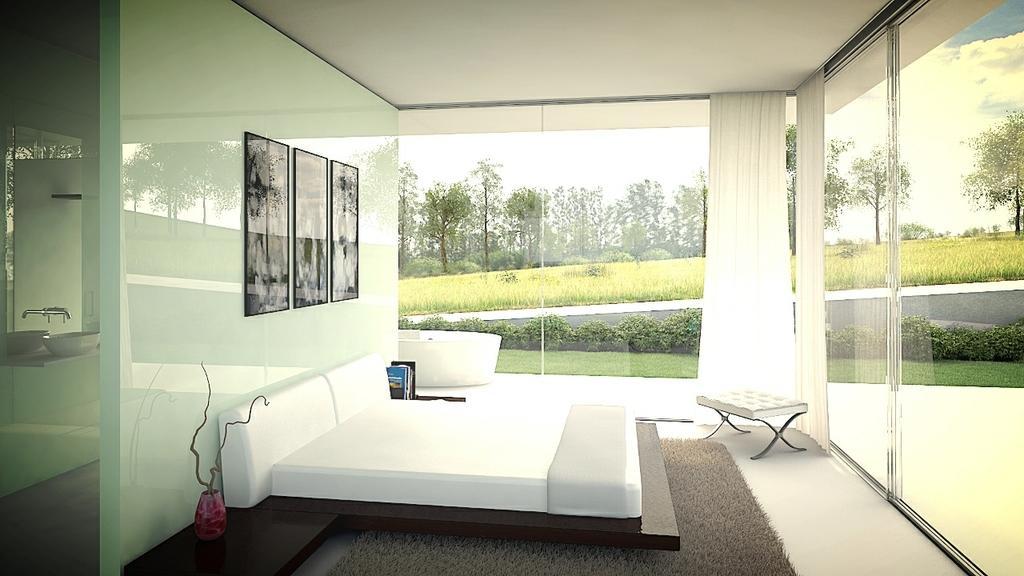Could you give a brief overview of what you see in this image? In this picture I can see the photo frames on the wall. I can see the bed and sitting chair. I can see glass walls. I can see wash basin and mirror on the left side. I can see the curtains. I can see green grass. I can see trees. I can see clouds in the sky. 